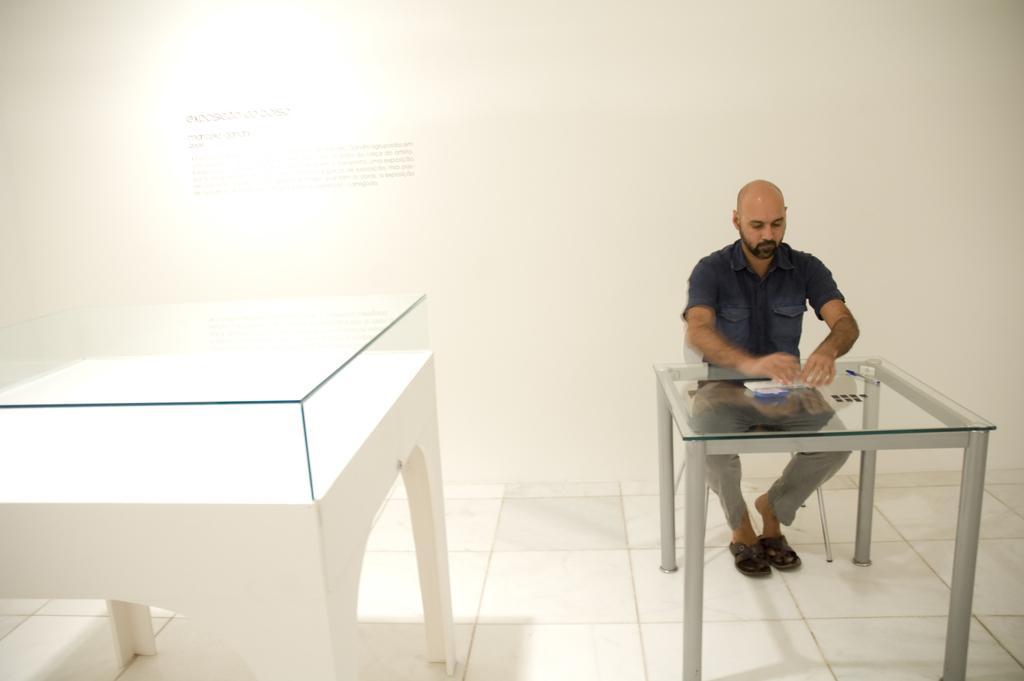Describe this image in one or two sentences. In this picture we can see man sitting on chair and in front of him there is a table beside to him we have glass box placed on a table and in the background we can see wall. 